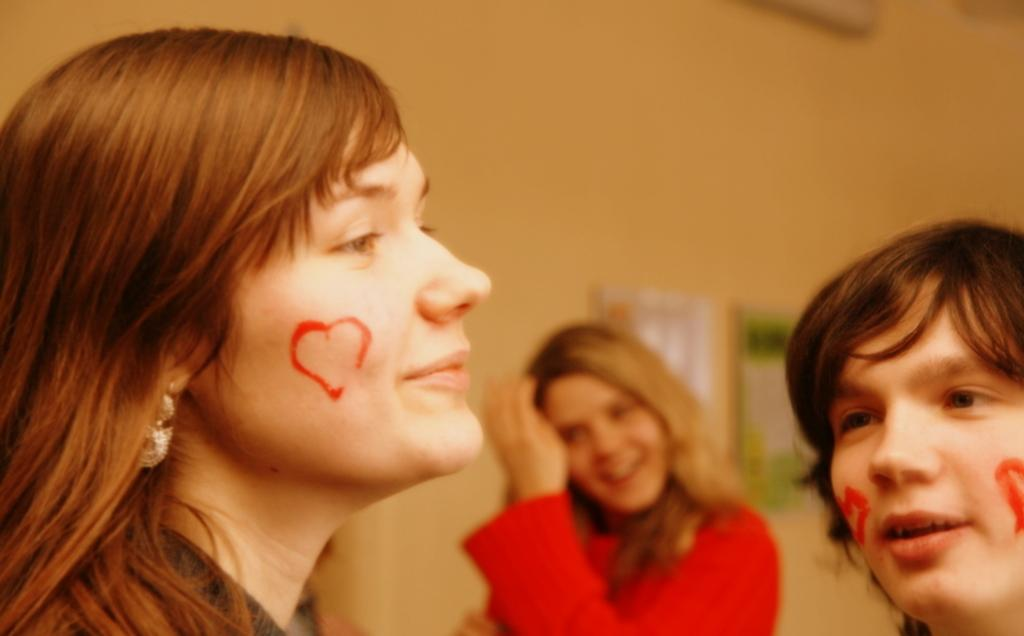What is happening in the image? There are people standing in the image. What can be observed on the faces of some people? There are paintings on the faces of some people. What is the background of the image? There is a wall visible in the image. What type of bells can be heard ringing in the image? There are no bells present in the image, and therefore no sound can be heard. 